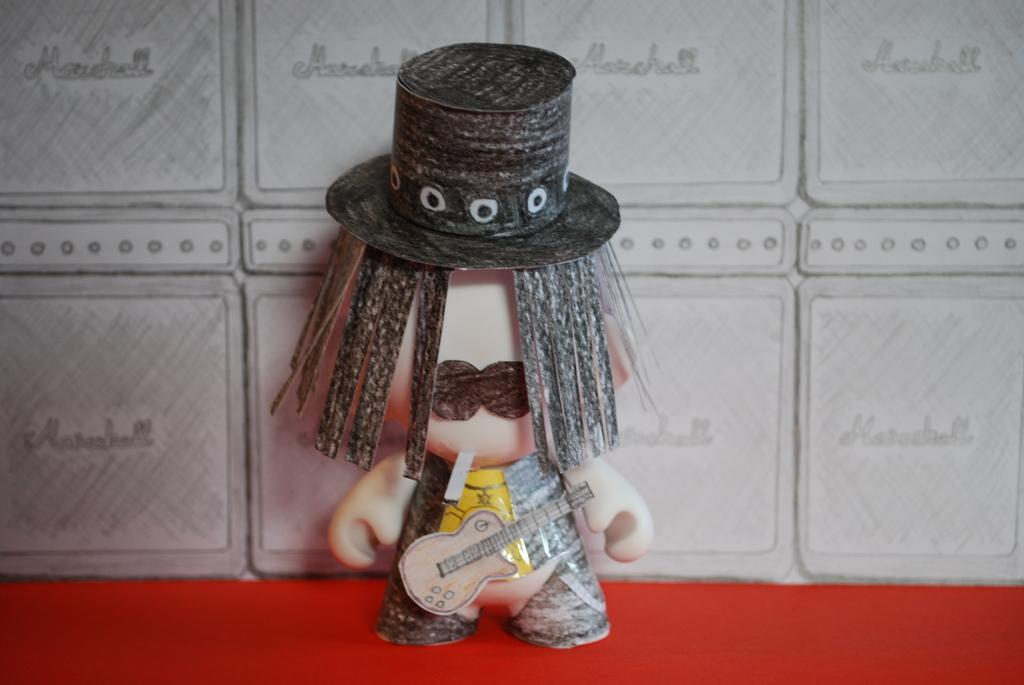What object is present in the image that resembles a toy? There is a toy in the image. Where is the toy located in the image? The toy is placed on a table. What grade of wood is used to construct the beam in the image? There is no beam present in the image, and therefore no such construction material can be identified. 